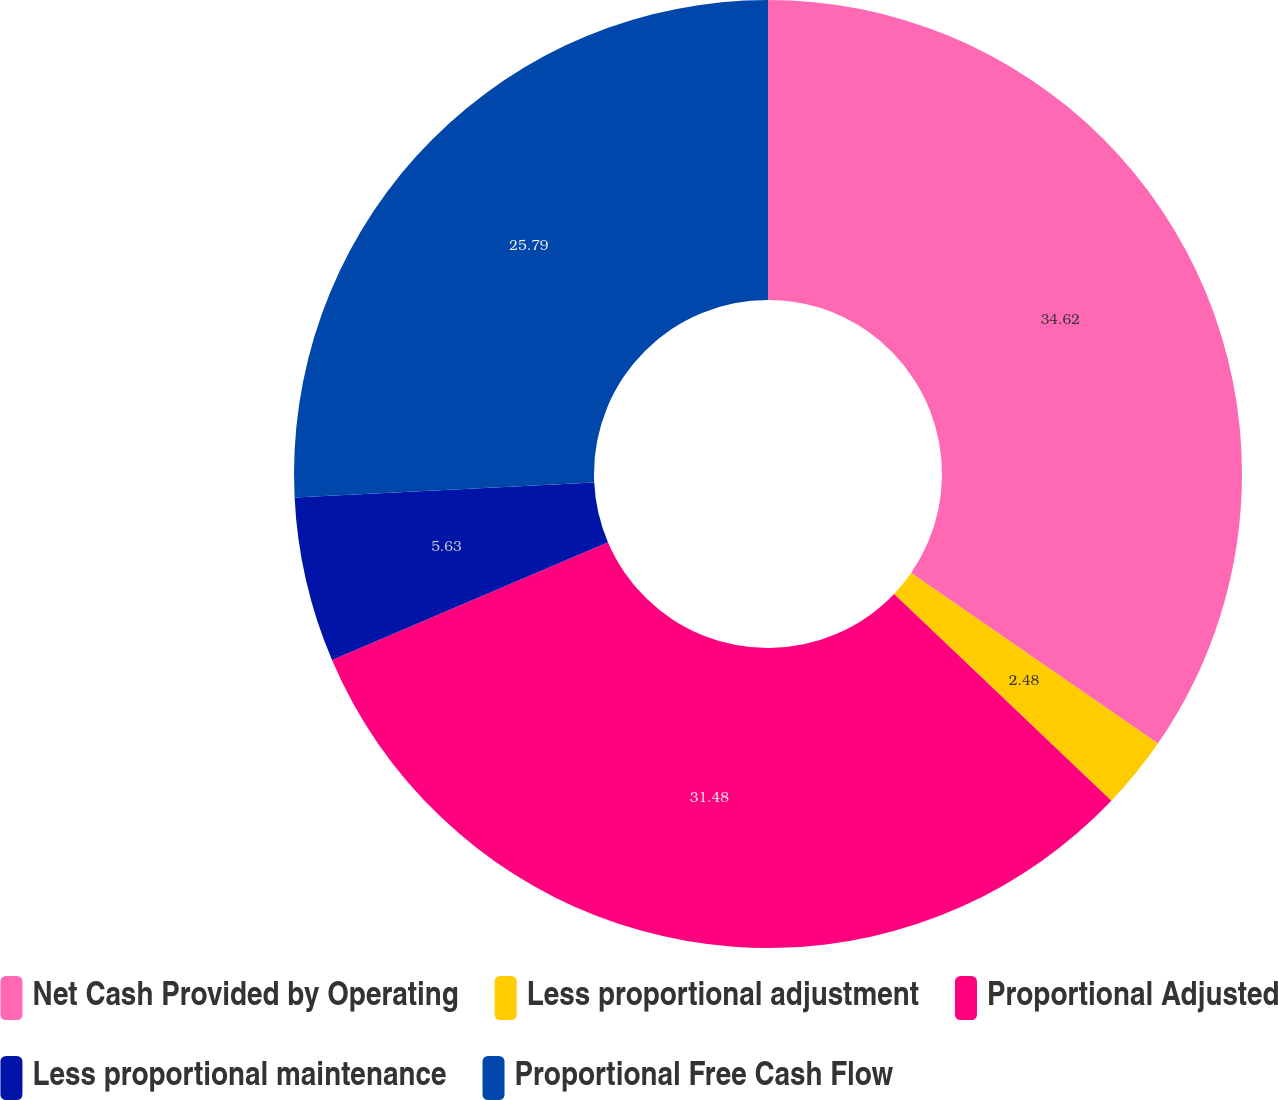Convert chart. <chart><loc_0><loc_0><loc_500><loc_500><pie_chart><fcel>Net Cash Provided by Operating<fcel>Less proportional adjustment<fcel>Proportional Adjusted<fcel>Less proportional maintenance<fcel>Proportional Free Cash Flow<nl><fcel>34.63%<fcel>2.48%<fcel>31.48%<fcel>5.63%<fcel>25.79%<nl></chart> 